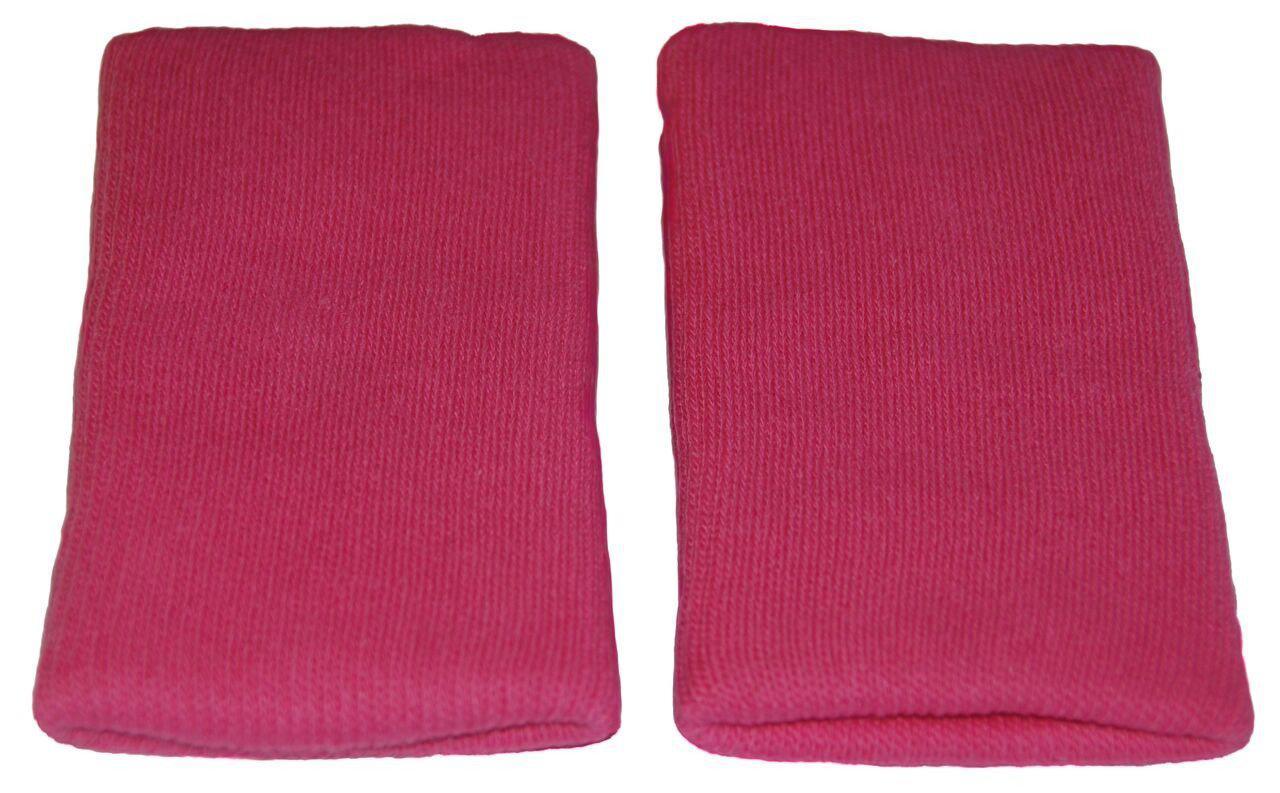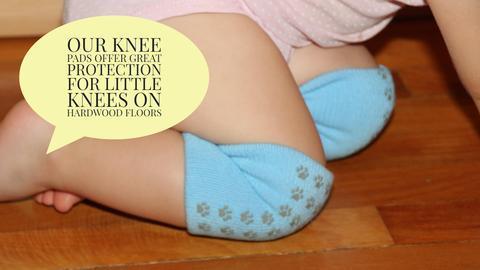The first image is the image on the left, the second image is the image on the right. Given the left and right images, does the statement "The left and right image contains the same number of soft knit wrist guards." hold true? Answer yes or no. No. The first image is the image on the left, the second image is the image on the right. Considering the images on both sides, is "One image shows a pair of toddler knees kneeling on a wood floor and wearing colored knee pads with paw prints on them." valid? Answer yes or no. Yes. 